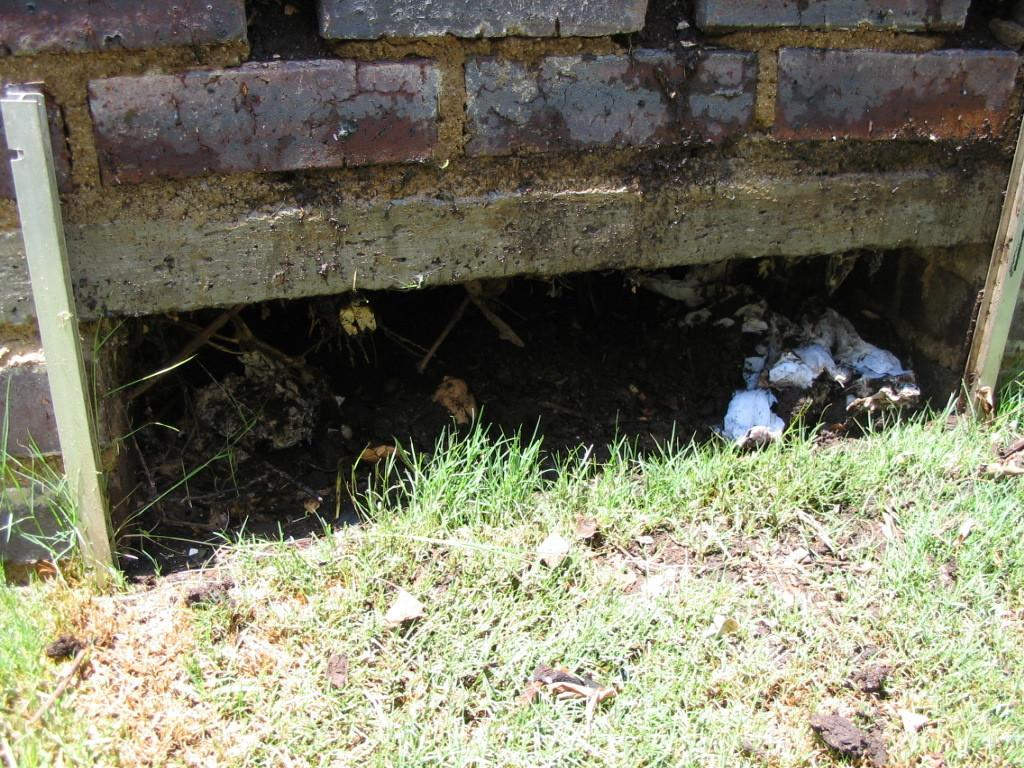What type of vegetation can be seen in the image? There is grass in the image. What are the rods in the image used for? The purpose of the rods in the image is not specified, but they are present in the image. What is the background of the image? There is a wall in the image, which serves as the background. What type of experience can be gained from the poison in the image? There is no poison present in the image, so it is not possible to gain any experience from it. 